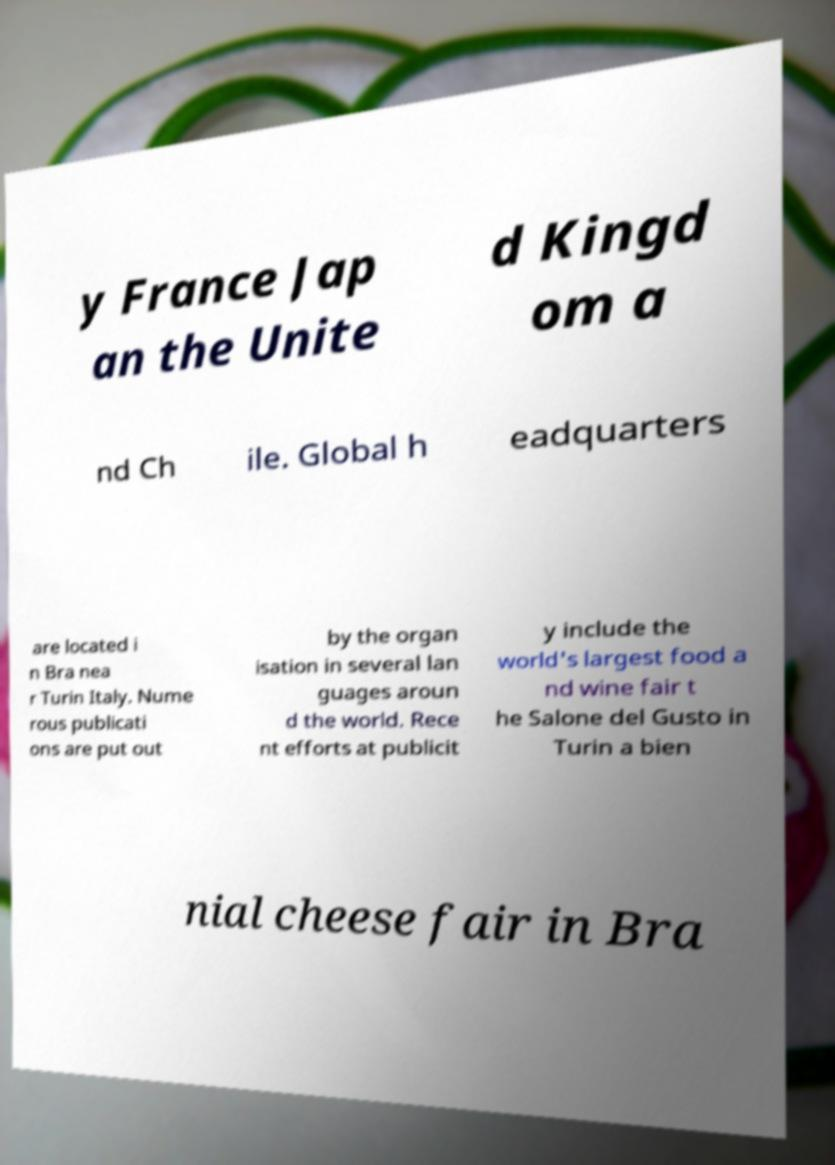Can you read and provide the text displayed in the image?This photo seems to have some interesting text. Can you extract and type it out for me? y France Jap an the Unite d Kingd om a nd Ch ile. Global h eadquarters are located i n Bra nea r Turin Italy. Nume rous publicati ons are put out by the organ isation in several lan guages aroun d the world. Rece nt efforts at publicit y include the world's largest food a nd wine fair t he Salone del Gusto in Turin a bien nial cheese fair in Bra 